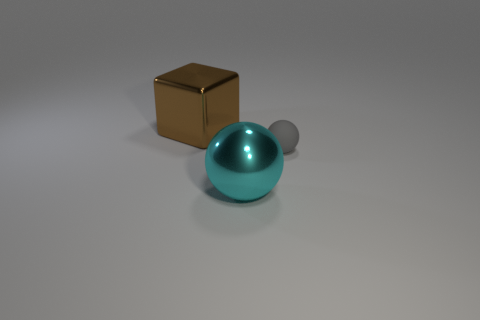What number of gray rubber things have the same size as the shiny sphere?
Your response must be concise. 0. Do the large thing that is to the right of the brown cube and the small object have the same material?
Your answer should be compact. No. Are there fewer large balls on the left side of the brown shiny cube than cyan metal balls?
Ensure brevity in your answer.  Yes. What shape is the metal object that is behind the large cyan thing?
Provide a succinct answer. Cube. What is the shape of the metal object that is the same size as the cyan sphere?
Keep it short and to the point. Cube. Is there another gray object that has the same shape as the small gray object?
Your answer should be very brief. No. Does the large thing that is to the right of the brown metal thing have the same shape as the big thing behind the gray matte thing?
Offer a very short reply. No. What is the material of the thing that is the same size as the metal cube?
Keep it short and to the point. Metal. How many other things are there of the same material as the large brown cube?
Offer a terse response. 1. The cyan object that is on the right side of the big metal object behind the cyan thing is what shape?
Your response must be concise. Sphere. 